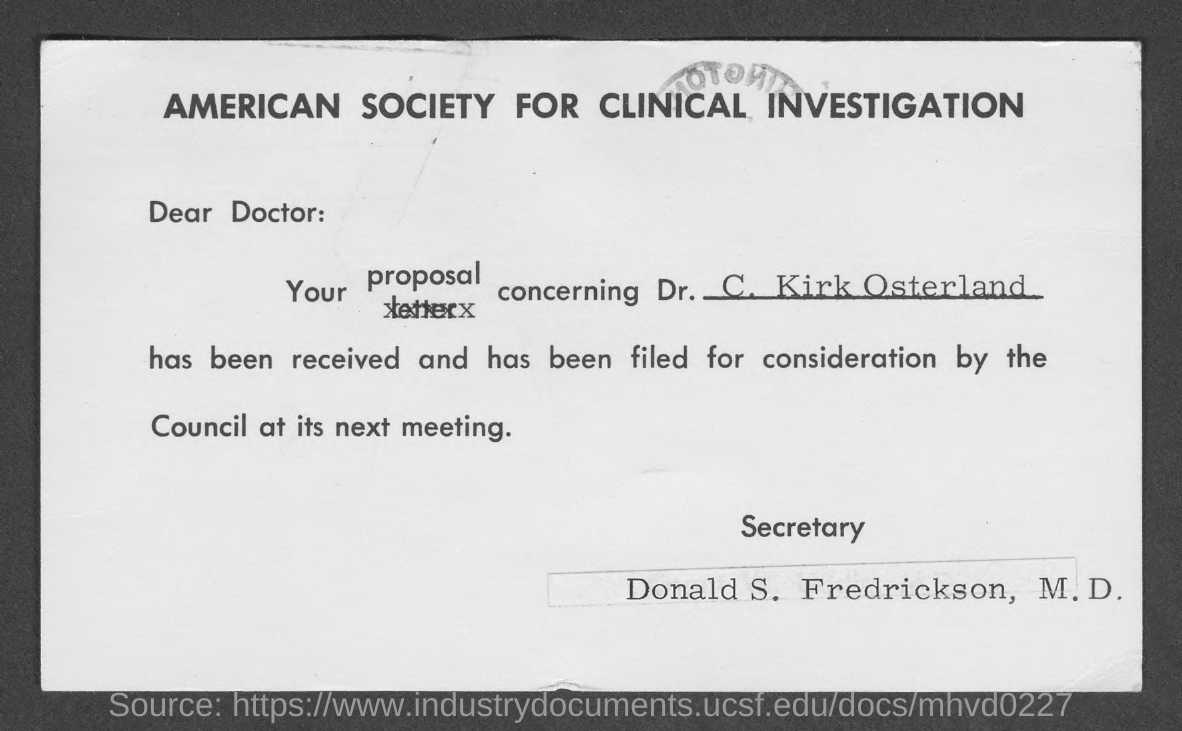Mention a couple of crucial points in this snapshot. Donald S. Fredrickson, M.D., is the secretary. The proposition is concerning Dr. C. Kirk Osterland. 